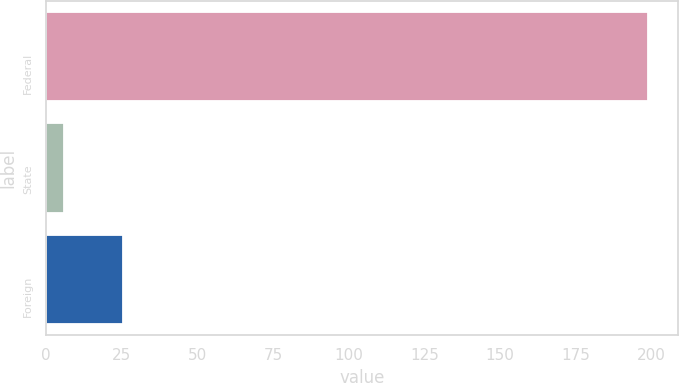<chart> <loc_0><loc_0><loc_500><loc_500><bar_chart><fcel>Federal<fcel>State<fcel>Foreign<nl><fcel>199<fcel>6<fcel>25.3<nl></chart> 